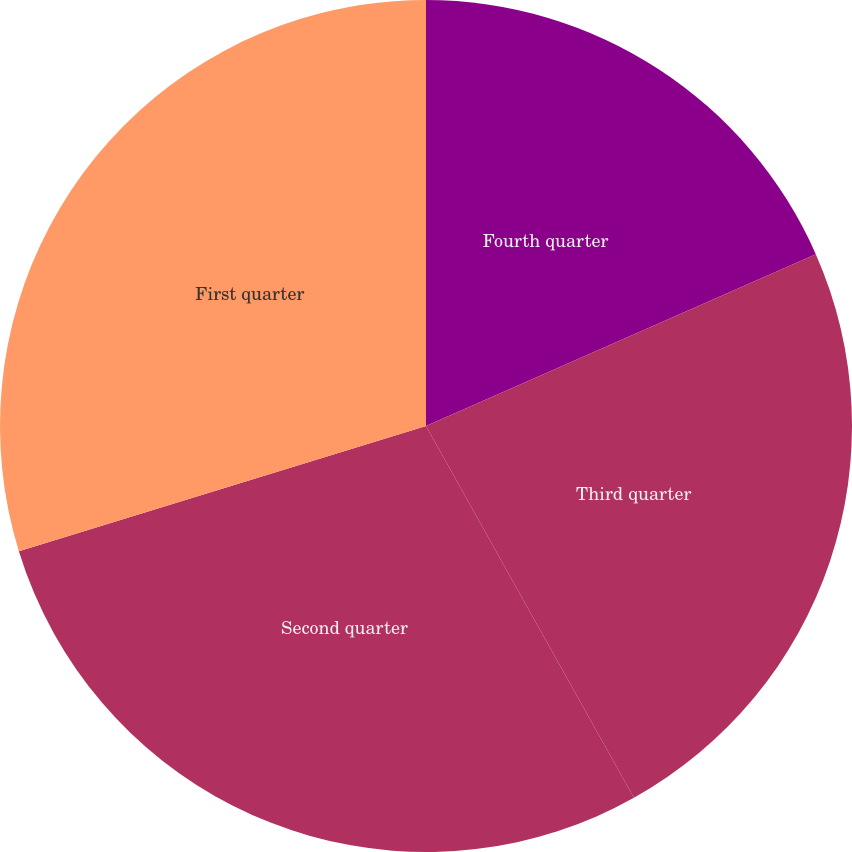Convert chart to OTSL. <chart><loc_0><loc_0><loc_500><loc_500><pie_chart><fcel>Fourth quarter<fcel>Third quarter<fcel>Second quarter<fcel>First quarter<nl><fcel>18.39%<fcel>23.49%<fcel>28.36%<fcel>29.75%<nl></chart> 